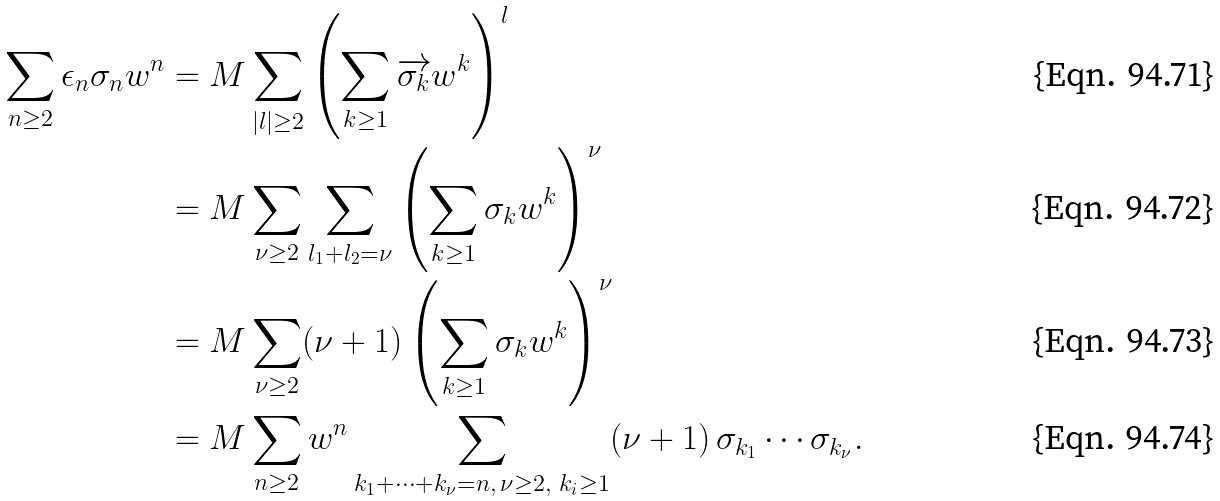Convert formula to latex. <formula><loc_0><loc_0><loc_500><loc_500>\sum _ { n \geq 2 } \epsilon _ { n } \sigma _ { n } w ^ { n } & = M \sum _ { | l | \geq 2 } \left ( \sum _ { k \geq 1 } \overrightarrow { \sigma _ { k } } w ^ { k } \right ) ^ { l } \\ & = M \sum _ { \nu \geq 2 } \sum _ { l _ { 1 } + l _ { 2 } = \nu } \left ( \sum _ { k \geq 1 } \sigma _ { k } w ^ { k } \right ) ^ { \nu } \\ & = M \sum _ { \nu \geq 2 } ( \nu + 1 ) \left ( \sum _ { k \geq 1 } \sigma _ { k } w ^ { k } \right ) ^ { \nu } \\ & = M \sum _ { n \geq 2 } w ^ { n } \sum _ { k _ { 1 } + \cdots + k _ { \nu } = n , \, \nu \geq 2 , \ k _ { i } \geq 1 } ( \nu + 1 ) \, \sigma _ { k _ { 1 } } \cdots \sigma _ { k _ { \nu } } .</formula> 